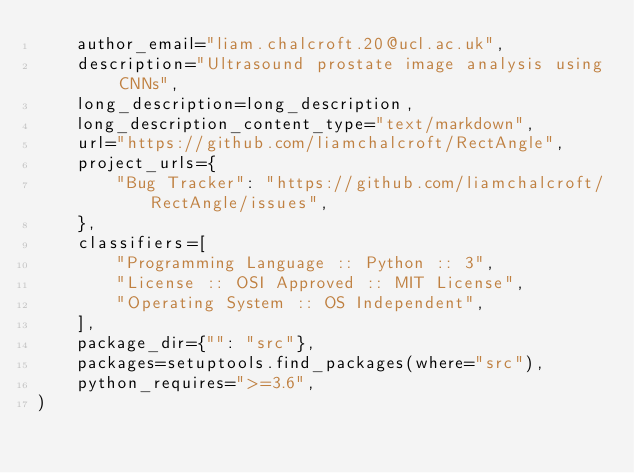<code> <loc_0><loc_0><loc_500><loc_500><_Python_>    author_email="liam.chalcroft.20@ucl.ac.uk",
    description="Ultrasound prostate image analysis using CNNs",
    long_description=long_description,
    long_description_content_type="text/markdown",
    url="https://github.com/liamchalcroft/RectAngle",
    project_urls={
        "Bug Tracker": "https://github.com/liamchalcroft/RectAngle/issues",
    },
    classifiers=[
        "Programming Language :: Python :: 3",
        "License :: OSI Approved :: MIT License",
        "Operating System :: OS Independent",
    ],
    package_dir={"": "src"},
    packages=setuptools.find_packages(where="src"),
    python_requires=">=3.6",
)</code> 